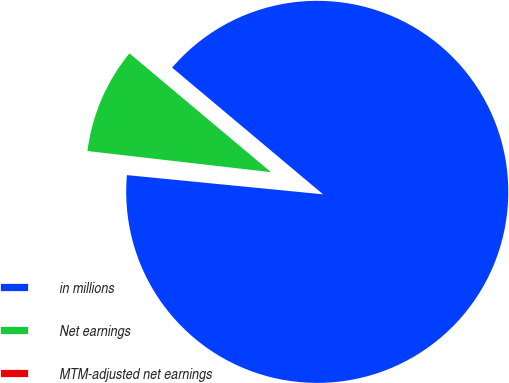Convert chart to OTSL. <chart><loc_0><loc_0><loc_500><loc_500><pie_chart><fcel>in millions<fcel>Net earnings<fcel>MTM-adjusted net earnings<nl><fcel>90.44%<fcel>9.29%<fcel>0.27%<nl></chart> 